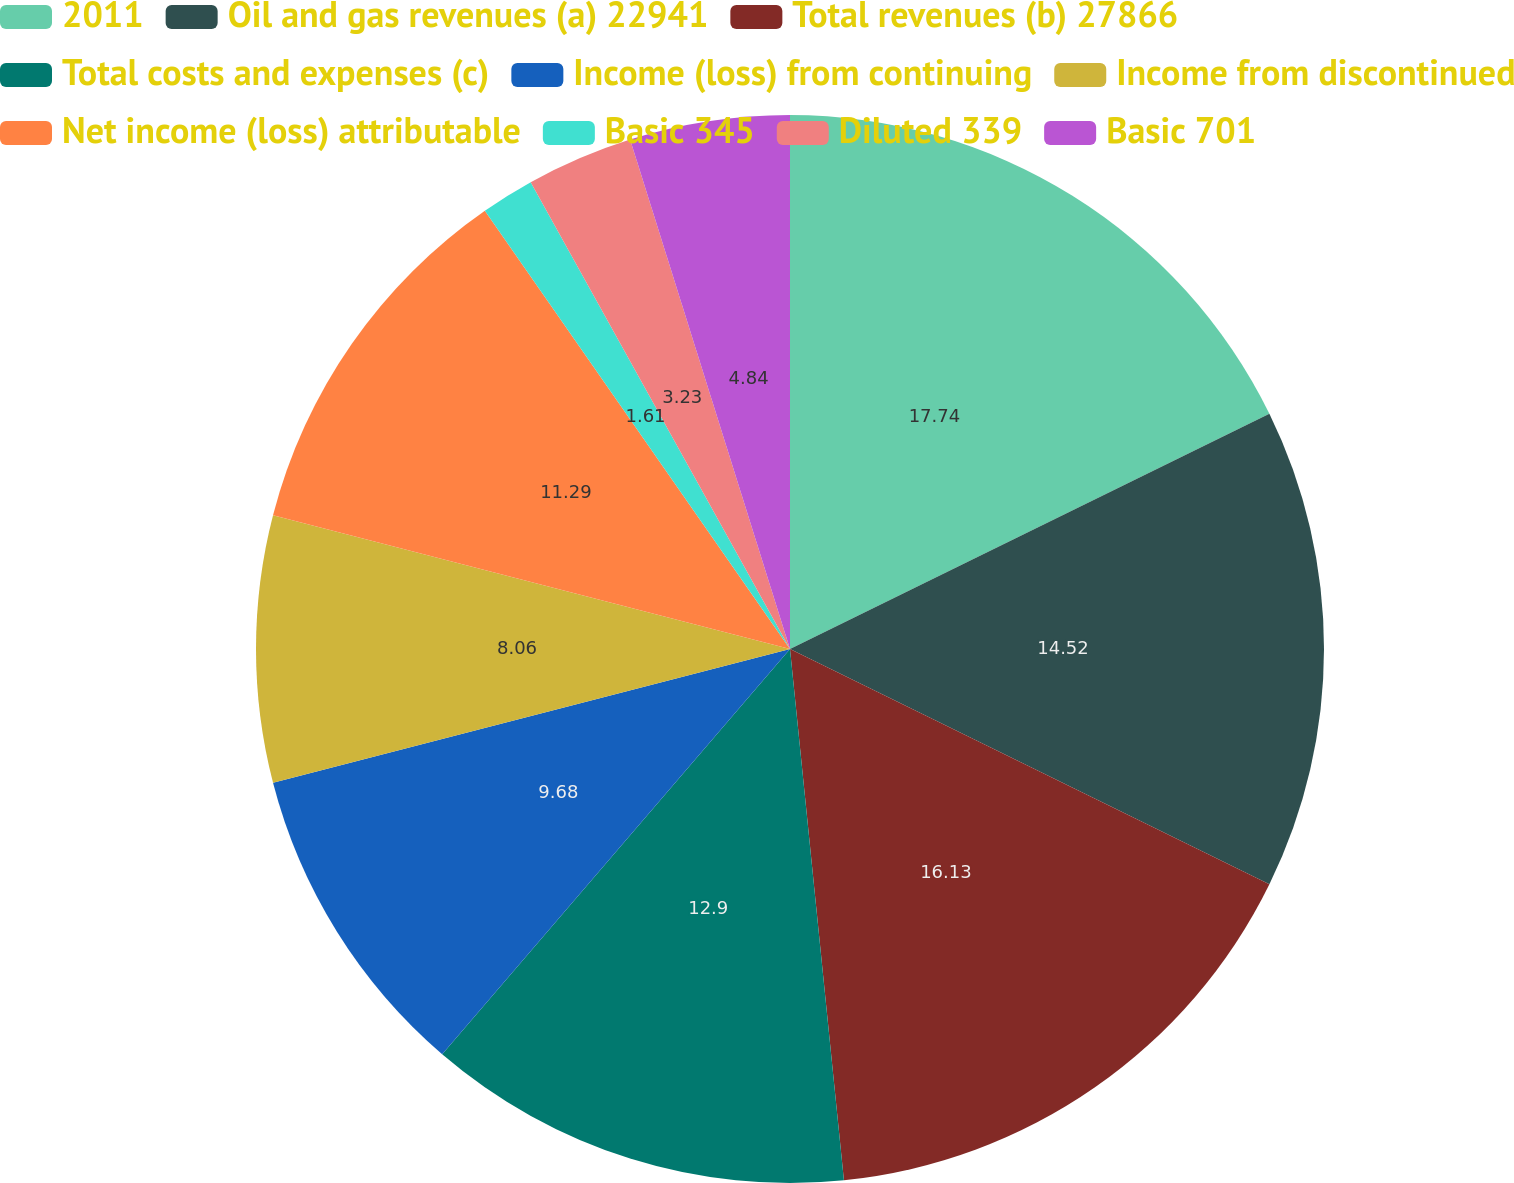Convert chart. <chart><loc_0><loc_0><loc_500><loc_500><pie_chart><fcel>2011<fcel>Oil and gas revenues (a) 22941<fcel>Total revenues (b) 27866<fcel>Total costs and expenses (c)<fcel>Income (loss) from continuing<fcel>Income from discontinued<fcel>Net income (loss) attributable<fcel>Basic 345<fcel>Diluted 339<fcel>Basic 701<nl><fcel>17.74%<fcel>14.52%<fcel>16.13%<fcel>12.9%<fcel>9.68%<fcel>8.06%<fcel>11.29%<fcel>1.61%<fcel>3.23%<fcel>4.84%<nl></chart> 